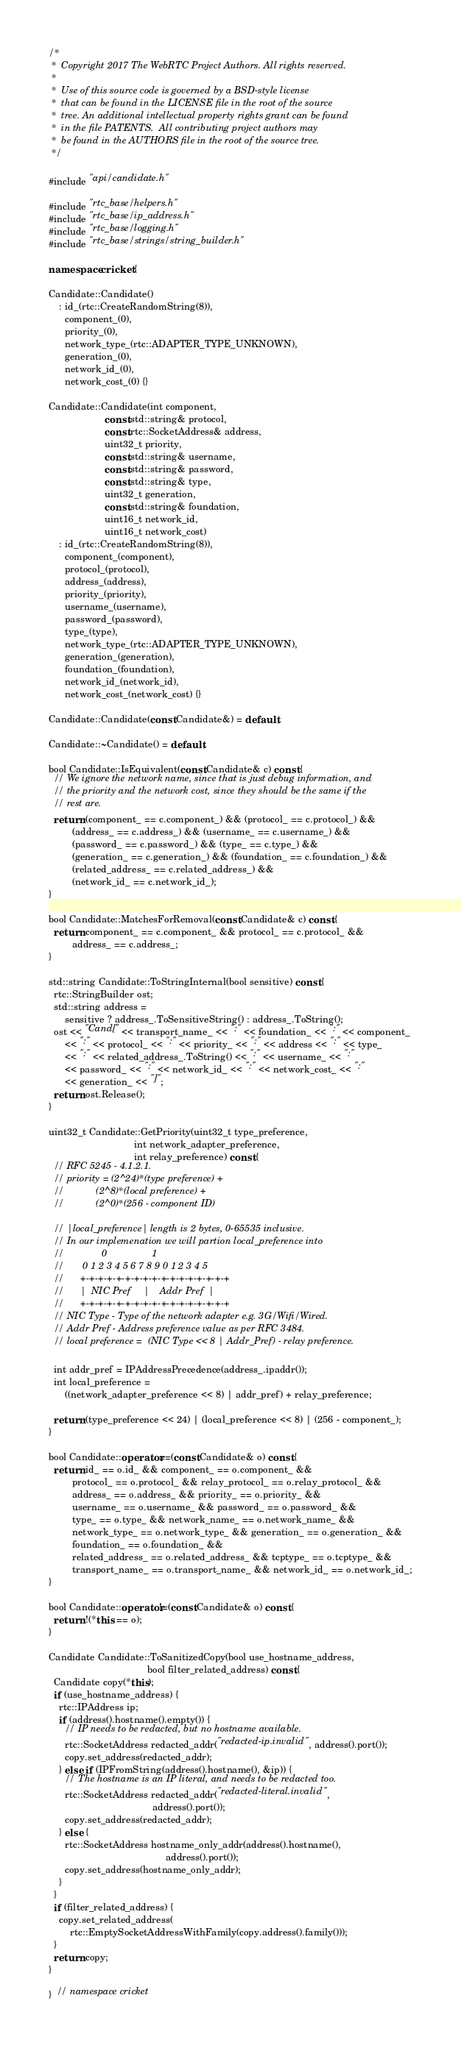Convert code to text. <code><loc_0><loc_0><loc_500><loc_500><_C++_>/*
 *  Copyright 2017 The WebRTC Project Authors. All rights reserved.
 *
 *  Use of this source code is governed by a BSD-style license
 *  that can be found in the LICENSE file in the root of the source
 *  tree. An additional intellectual property rights grant can be found
 *  in the file PATENTS.  All contributing project authors may
 *  be found in the AUTHORS file in the root of the source tree.
 */

#include "api/candidate.h"

#include "rtc_base/helpers.h"
#include "rtc_base/ip_address.h"
#include "rtc_base/logging.h"
#include "rtc_base/strings/string_builder.h"

namespace cricket {

Candidate::Candidate()
    : id_(rtc::CreateRandomString(8)),
      component_(0),
      priority_(0),
      network_type_(rtc::ADAPTER_TYPE_UNKNOWN),
      generation_(0),
      network_id_(0),
      network_cost_(0) {}

Candidate::Candidate(int component,
                     const std::string& protocol,
                     const rtc::SocketAddress& address,
                     uint32_t priority,
                     const std::string& username,
                     const std::string& password,
                     const std::string& type,
                     uint32_t generation,
                     const std::string& foundation,
                     uint16_t network_id,
                     uint16_t network_cost)
    : id_(rtc::CreateRandomString(8)),
      component_(component),
      protocol_(protocol),
      address_(address),
      priority_(priority),
      username_(username),
      password_(password),
      type_(type),
      network_type_(rtc::ADAPTER_TYPE_UNKNOWN),
      generation_(generation),
      foundation_(foundation),
      network_id_(network_id),
      network_cost_(network_cost) {}

Candidate::Candidate(const Candidate&) = default;

Candidate::~Candidate() = default;

bool Candidate::IsEquivalent(const Candidate& c) const {
  // We ignore the network name, since that is just debug information, and
  // the priority and the network cost, since they should be the same if the
  // rest are.
  return (component_ == c.component_) && (protocol_ == c.protocol_) &&
         (address_ == c.address_) && (username_ == c.username_) &&
         (password_ == c.password_) && (type_ == c.type_) &&
         (generation_ == c.generation_) && (foundation_ == c.foundation_) &&
         (related_address_ == c.related_address_) &&
         (network_id_ == c.network_id_);
}

bool Candidate::MatchesForRemoval(const Candidate& c) const {
  return component_ == c.component_ && protocol_ == c.protocol_ &&
         address_ == c.address_;
}

std::string Candidate::ToStringInternal(bool sensitive) const {
  rtc::StringBuilder ost;
  std::string address =
      sensitive ? address_.ToSensitiveString() : address_.ToString();
  ost << "Cand[" << transport_name_ << ":" << foundation_ << ":" << component_
      << ":" << protocol_ << ":" << priority_ << ":" << address << ":" << type_
      << ":" << related_address_.ToString() << ":" << username_ << ":"
      << password_ << ":" << network_id_ << ":" << network_cost_ << ":"
      << generation_ << "]";
  return ost.Release();
}

uint32_t Candidate::GetPriority(uint32_t type_preference,
                                int network_adapter_preference,
                                int relay_preference) const {
  // RFC 5245 - 4.1.2.1.
  // priority = (2^24)*(type preference) +
  //            (2^8)*(local preference) +
  //            (2^0)*(256 - component ID)

  // |local_preference| length is 2 bytes, 0-65535 inclusive.
  // In our implemenation we will partion local_preference into
  //              0                 1
  //       0 1 2 3 4 5 6 7 8 9 0 1 2 3 4 5
  //      +-+-+-+-+-+-+-+-+-+-+-+-+-+-+-+-+
  //      |  NIC Pref     |    Addr Pref  |
  //      +-+-+-+-+-+-+-+-+-+-+-+-+-+-+-+-+
  // NIC Type - Type of the network adapter e.g. 3G/Wifi/Wired.
  // Addr Pref - Address preference value as per RFC 3484.
  // local preference =  (NIC Type << 8 | Addr_Pref) - relay preference.

  int addr_pref = IPAddressPrecedence(address_.ipaddr());
  int local_preference =
      ((network_adapter_preference << 8) | addr_pref) + relay_preference;

  return (type_preference << 24) | (local_preference << 8) | (256 - component_);
}

bool Candidate::operator==(const Candidate& o) const {
  return id_ == o.id_ && component_ == o.component_ &&
         protocol_ == o.protocol_ && relay_protocol_ == o.relay_protocol_ &&
         address_ == o.address_ && priority_ == o.priority_ &&
         username_ == o.username_ && password_ == o.password_ &&
         type_ == o.type_ && network_name_ == o.network_name_ &&
         network_type_ == o.network_type_ && generation_ == o.generation_ &&
         foundation_ == o.foundation_ &&
         related_address_ == o.related_address_ && tcptype_ == o.tcptype_ &&
         transport_name_ == o.transport_name_ && network_id_ == o.network_id_;
}

bool Candidate::operator!=(const Candidate& o) const {
  return !(*this == o);
}

Candidate Candidate::ToSanitizedCopy(bool use_hostname_address,
                                     bool filter_related_address) const {
  Candidate copy(*this);
  if (use_hostname_address) {
    rtc::IPAddress ip;
    if (address().hostname().empty()) {
      // IP needs to be redacted, but no hostname available.
      rtc::SocketAddress redacted_addr("redacted-ip.invalid", address().port());
      copy.set_address(redacted_addr);
    } else if (IPFromString(address().hostname(), &ip)) {
      // The hostname is an IP literal, and needs to be redacted too.
      rtc::SocketAddress redacted_addr("redacted-literal.invalid",
                                       address().port());
      copy.set_address(redacted_addr);
    } else {
      rtc::SocketAddress hostname_only_addr(address().hostname(),
                                            address().port());
      copy.set_address(hostname_only_addr);
    }
  }
  if (filter_related_address) {
    copy.set_related_address(
        rtc::EmptySocketAddressWithFamily(copy.address().family()));
  }
  return copy;
}

}  // namespace cricket
</code> 